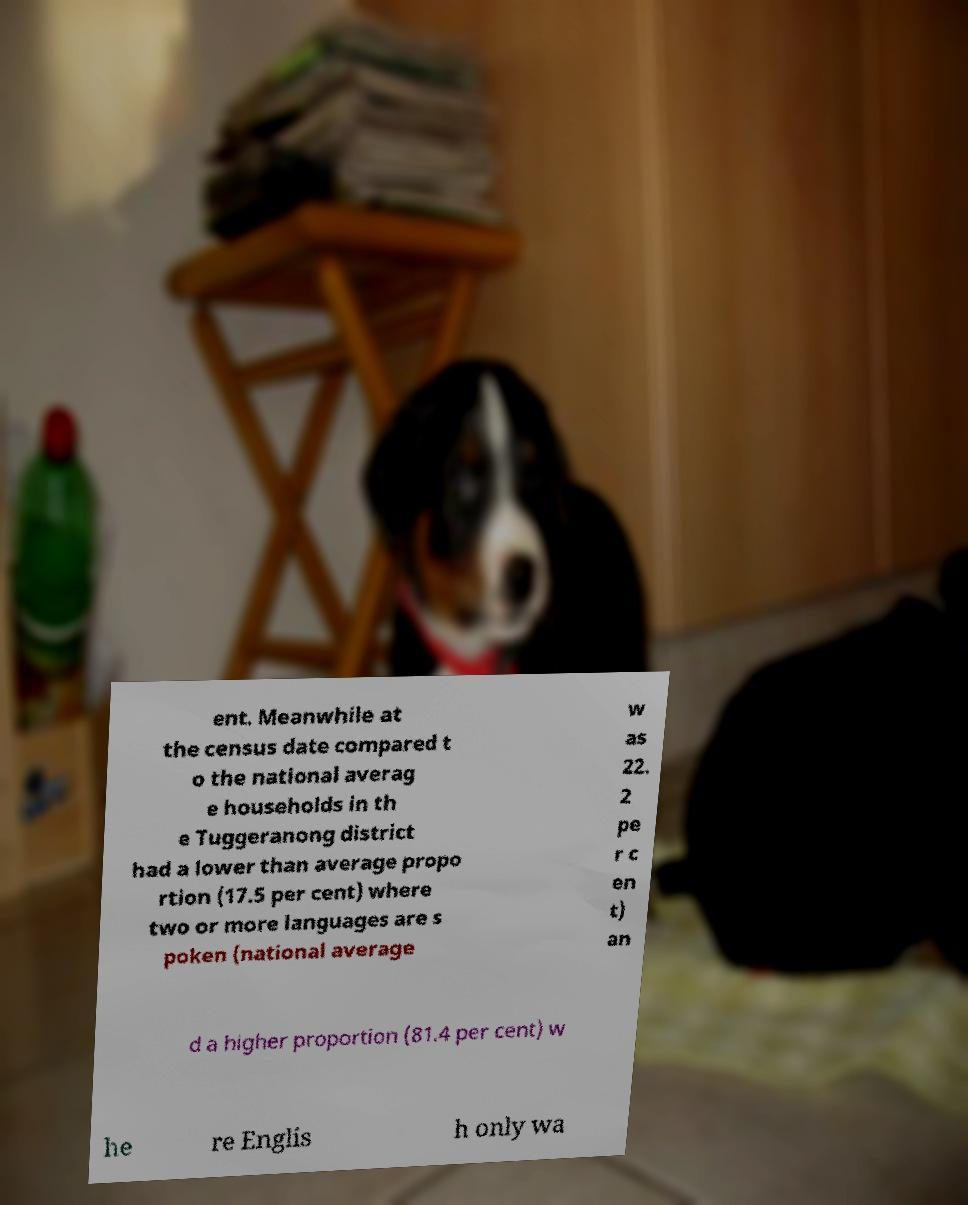Can you read and provide the text displayed in the image?This photo seems to have some interesting text. Can you extract and type it out for me? ent. Meanwhile at the census date compared t o the national averag e households in th e Tuggeranong district had a lower than average propo rtion (17.5 per cent) where two or more languages are s poken (national average w as 22. 2 pe r c en t) an d a higher proportion (81.4 per cent) w he re Englis h only wa 